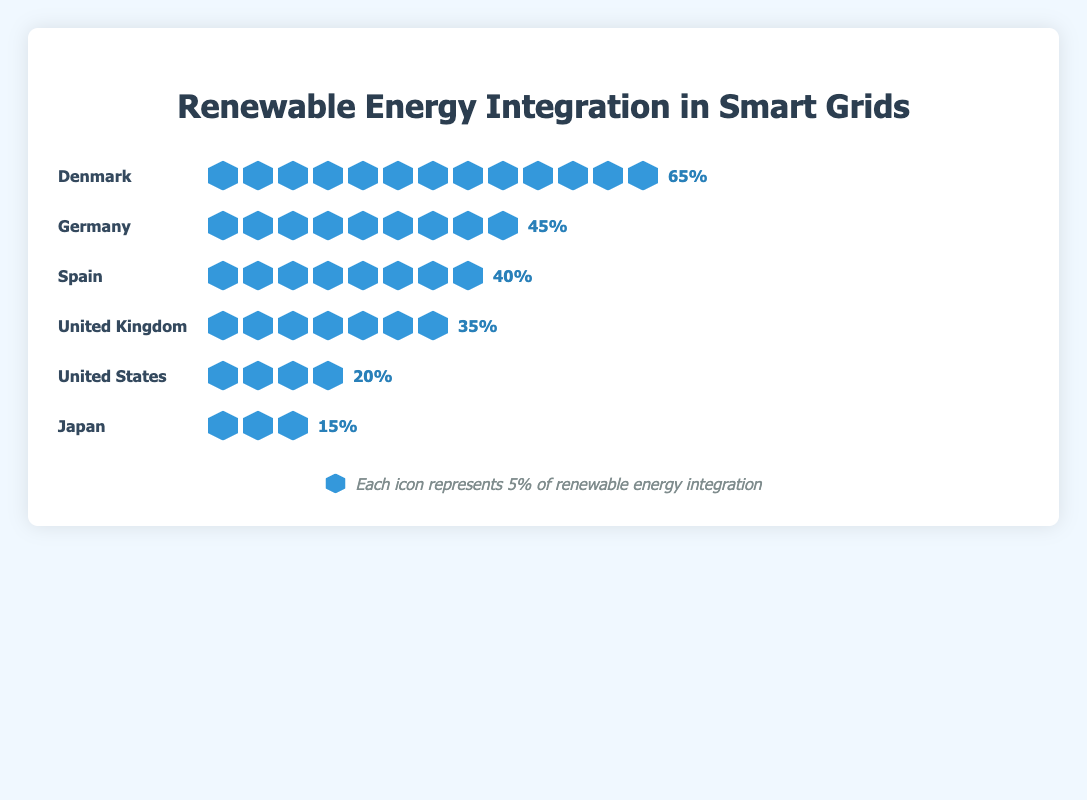What is the percentage of renewable energy integration in Denmark? The isotype plot shows that Denmark has 13 icons, each representing 5%, indicating the percentage is 13 * 5%.
Answer: 65% Which country has the lowest renewable energy integration? The isotype plot shows Japan with the least number of icons, only 3, indicating the lowest percentage of renewable energy integration.
Answer: Japan How many icons does Germany have? Counting the icons in the isotype plot for Germany, there are 9 icons.
Answer: 9 What is the total number of icons used to represent all six countries? Adding the icons for each country: 13 (Denmark) + 9 (Germany) + 8 (Spain) + 7 (United Kingdom) + 4 (United States) + 3 (Japan) equals 44 icons.
Answer: 44 What is the combined renewable energy integration percentage for Spain and the United Kingdom? Spain has 8 icons (40%) and the United Kingdom has 7 icons (35%), so combined it's 40% + 35%.
Answer: 75% Which countries have a renewable energy integration percentage higher than 40%? The countries with more than 8 icons (each representing 5%) are Denmark (13 icons, 65%) and Germany (9 icons, 45%).
Answer: Denmark, Germany How much higher is the renewable energy integration in Denmark compared to the United States? Denmark has 65% (13 icons) and the United States has 20% (4 icons), the difference is 65% - 20%.
Answer: 45% What is the average renewable energy integration percentage for all the countries? The total percentage is (65 + 45 + 40 + 35 + 20 + 15) = 220%, and the average is 220% / 6 countries.
Answer: 36.67% If each icon represents 5%, how many more icons are needed for Japan to reach the same renewable percentage as Germany? Germany has 9 icons (45%) and Japan has 3 icons (15%), Japan needs 9 - 3 = 6 more icons to match Germany's 45%.
Answer: 6 icons Which country has a renewable energy integration percentage closest to 50%? Germany has 9 icons which represent 45%, this is the closest to 50%.
Answer: Germany 